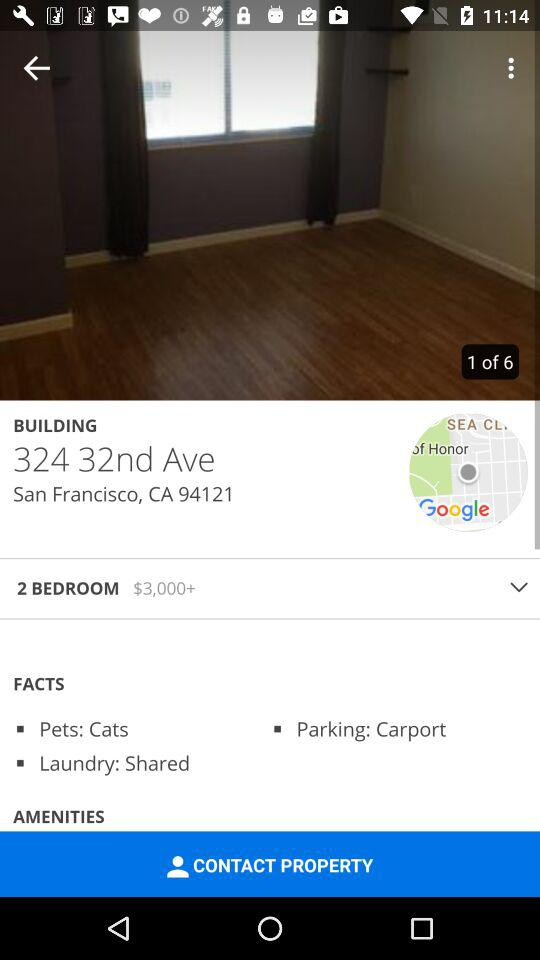How many bedrooms are there?
Answer the question using a single word or phrase. 2 